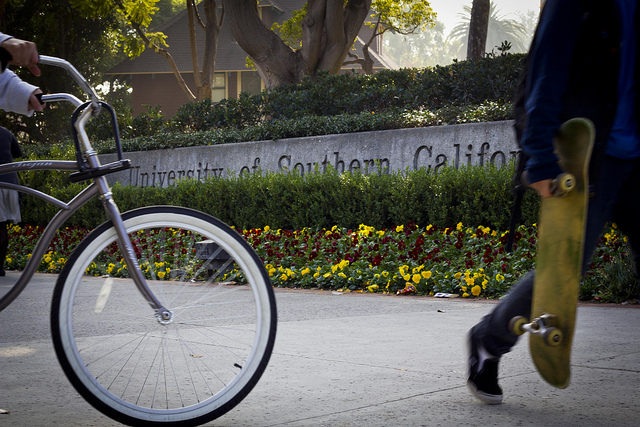Please identify all text content in this image. University of Southern Califo 